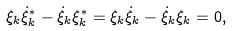<formula> <loc_0><loc_0><loc_500><loc_500>\xi _ { k } \dot { \xi } ^ { * } _ { k } - \dot { \xi } _ { k } \xi ^ { * } _ { k } = \xi _ { k } \dot { \xi } _ { k } - \dot { \xi } _ { k } \xi _ { k } = 0 ,</formula> 